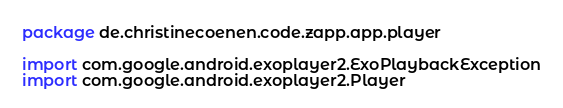<code> <loc_0><loc_0><loc_500><loc_500><_Kotlin_>package de.christinecoenen.code.zapp.app.player

import com.google.android.exoplayer2.ExoPlaybackException
import com.google.android.exoplayer2.Player</code> 